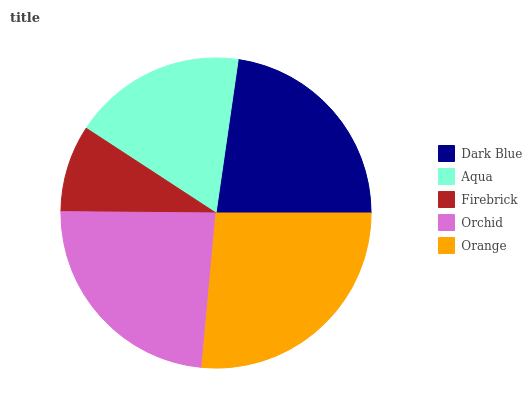Is Firebrick the minimum?
Answer yes or no. Yes. Is Orange the maximum?
Answer yes or no. Yes. Is Aqua the minimum?
Answer yes or no. No. Is Aqua the maximum?
Answer yes or no. No. Is Dark Blue greater than Aqua?
Answer yes or no. Yes. Is Aqua less than Dark Blue?
Answer yes or no. Yes. Is Aqua greater than Dark Blue?
Answer yes or no. No. Is Dark Blue less than Aqua?
Answer yes or no. No. Is Dark Blue the high median?
Answer yes or no. Yes. Is Dark Blue the low median?
Answer yes or no. Yes. Is Firebrick the high median?
Answer yes or no. No. Is Orange the low median?
Answer yes or no. No. 